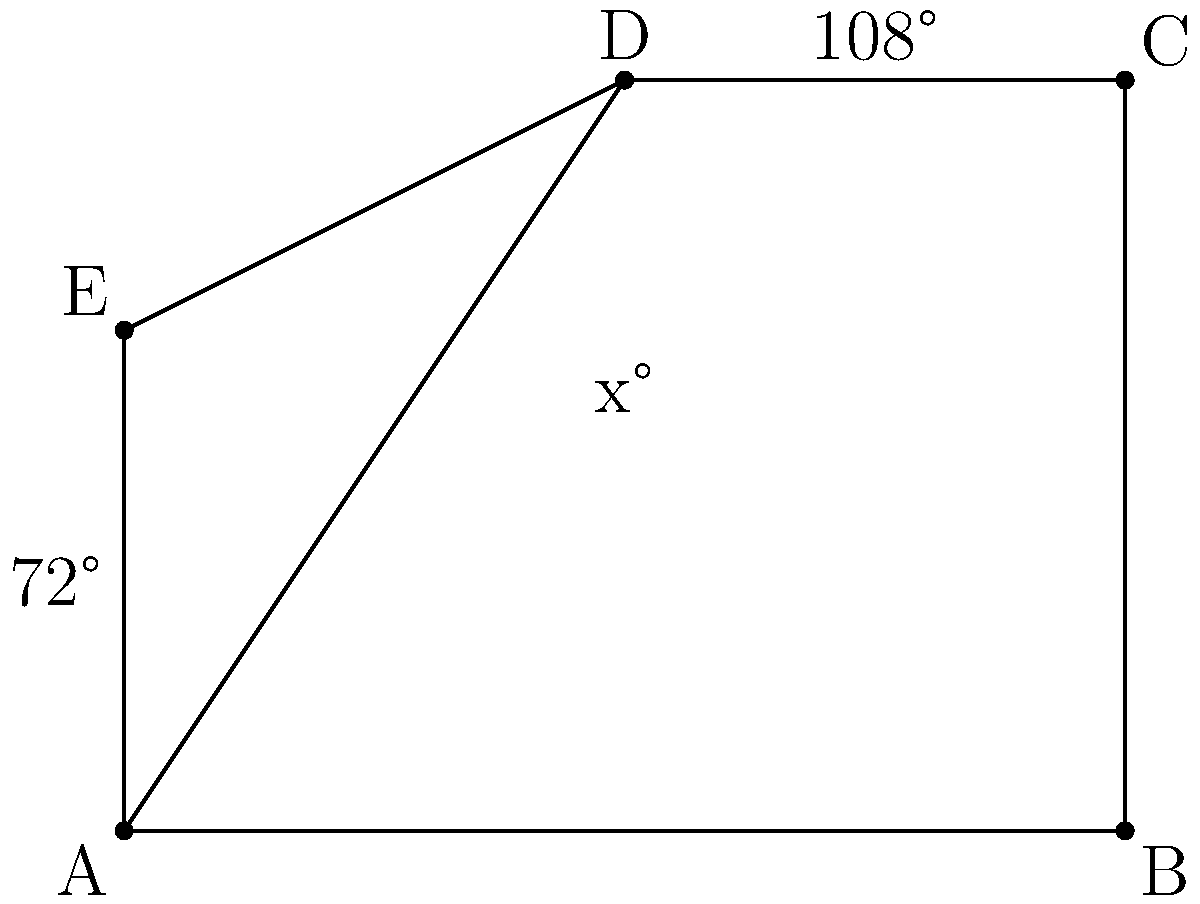In the floor plan of a medieval castle's great hall, represented by the pentagon ABCDE, two interior angles are known: angle EAB measures 72° and angle BCD measures 108°. If AD is a diagonal of the pentagon, what is the measure of angle DAB, represented by x in the diagram? To solve this problem, we'll use the properties of polygons and triangles:

1. The sum of interior angles of a pentagon is $(5-2) \times 180° = 540°$.

2. We know two angles: $\angle EAB = 72°$ and $\angle BCD = 108°$.

3. Let's denote the unknown angles: $\angle ABC = y°$, $\angle CDE = z°$, and $\angle DEA = w°$.

4. We can write an equation: $72° + y° + 108° + z° + w° = 540°$

5. The diagonal AD divides the pentagon into three triangles: ADE, ABD, and ACD.

6. In triangle ADE: $x° + w° + \angle AED = 180°$

7. In triangle ABD: $x° + y° + \angle ADB = 180°$

8. In triangle ACD: $\angle DAC + 108° + \angle ADB = 180°$

9. Adding equations from steps 6 and 7: $2x° + w° + y° + \angle AED + \angle ADB = 360°$

10. Substituting $\angle AED + \angle ADB = 180° - \angle DAC$ from step 8:
    $2x° + w° + y° + (180° - \angle DAC) = 360°$
    $2x° + w° + y° - \angle DAC = 180°$

11. From the pentagon equation in step 4:
    $w° + y° = 540° - 72° - 108° - z° = 360° - z°$

12. Substituting this into the equation from step 10:
    $2x° + (360° - z°) - \angle DAC = 180°$
    $2x° - z° - \angle DAC = -180°$

13. In the pentagon, $z° + \angle DAC = 180°$ (they form a straight line)

14. Substituting this into the equation from step 12:
    $2x° - 180° = -180°$
    $2x° = 0°$
    $x° = 0°$

Therefore, the measure of angle DAB (x) is 0°.
Answer: 0° 